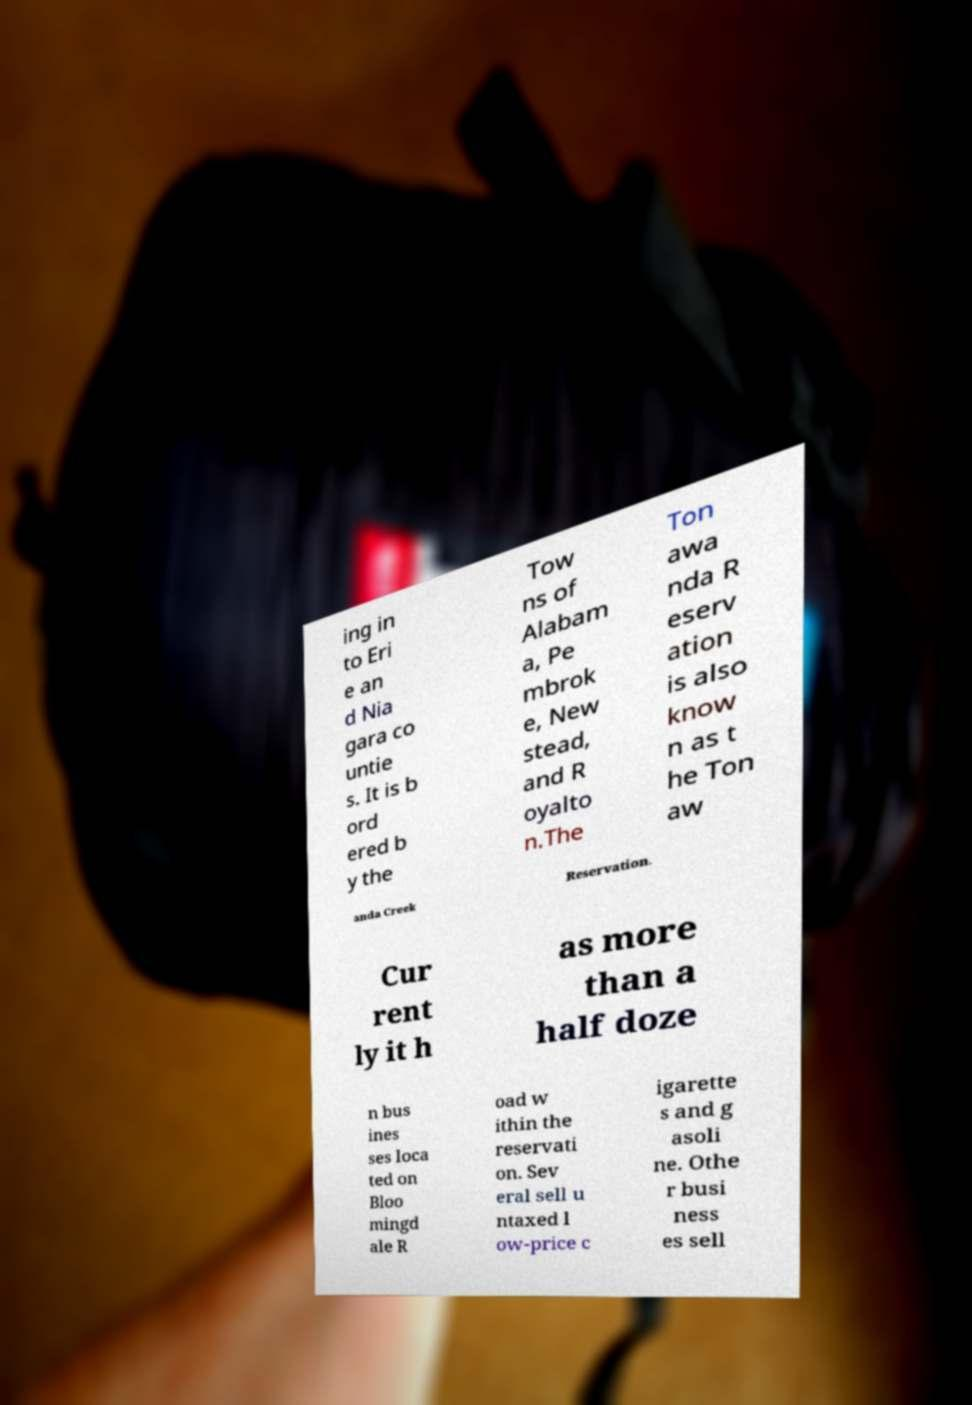Could you assist in decoding the text presented in this image and type it out clearly? ing in to Eri e an d Nia gara co untie s. It is b ord ered b y the Tow ns of Alabam a, Pe mbrok e, New stead, and R oyalto n.The Ton awa nda R eserv ation is also know n as t he Ton aw anda Creek Reservation. Cur rent ly it h as more than a half doze n bus ines ses loca ted on Bloo mingd ale R oad w ithin the reservati on. Sev eral sell u ntaxed l ow-price c igarette s and g asoli ne. Othe r busi ness es sell 